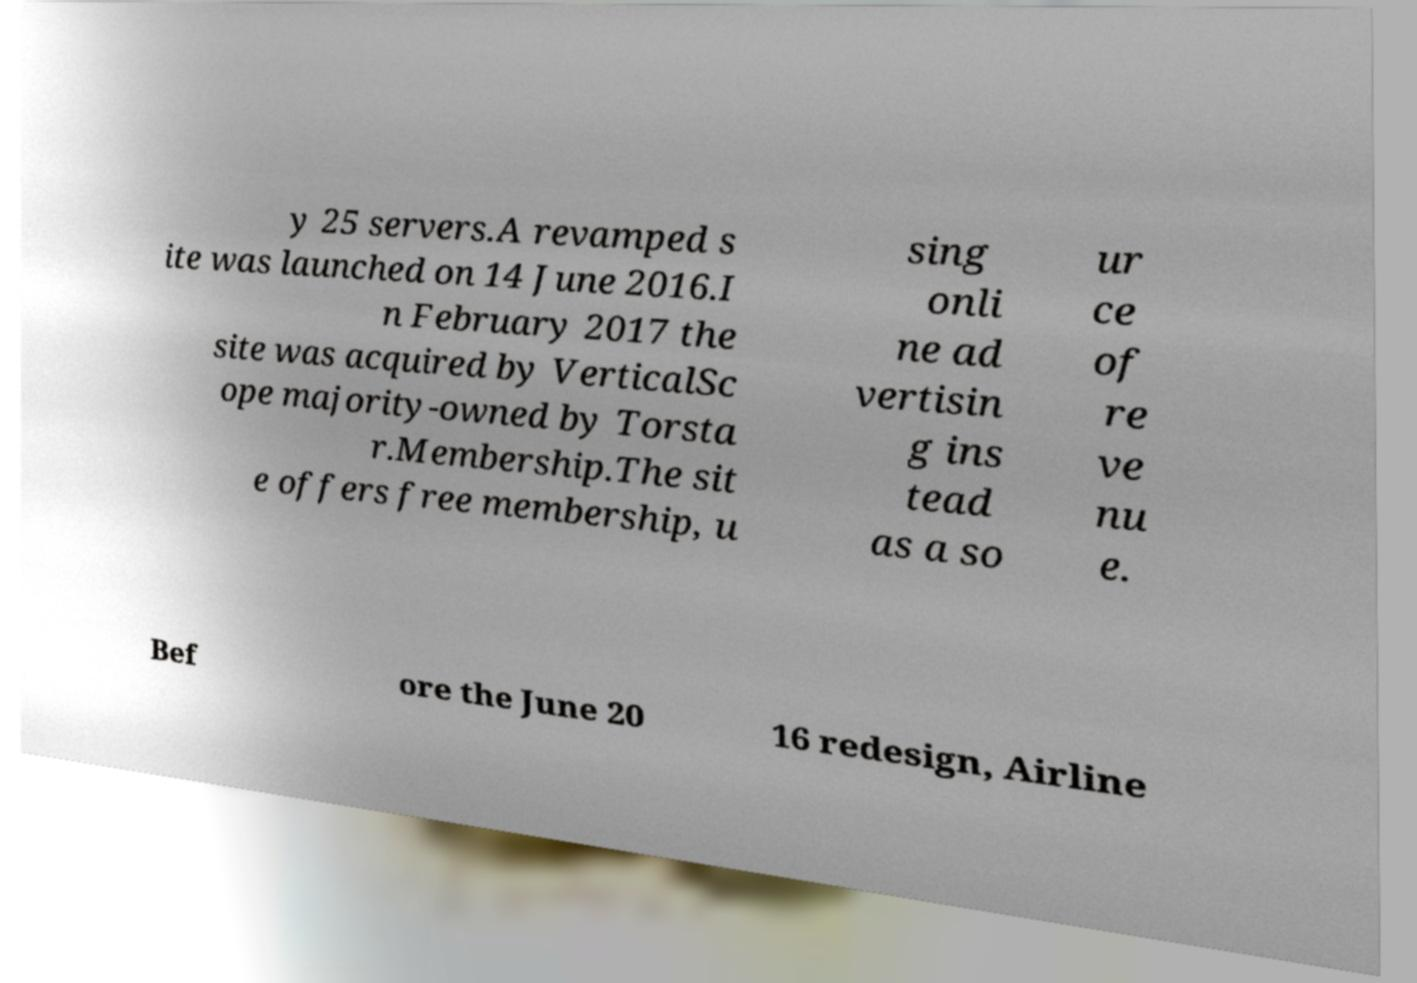Could you extract and type out the text from this image? y 25 servers.A revamped s ite was launched on 14 June 2016.I n February 2017 the site was acquired by VerticalSc ope majority-owned by Torsta r.Membership.The sit e offers free membership, u sing onli ne ad vertisin g ins tead as a so ur ce of re ve nu e. Bef ore the June 20 16 redesign, Airline 